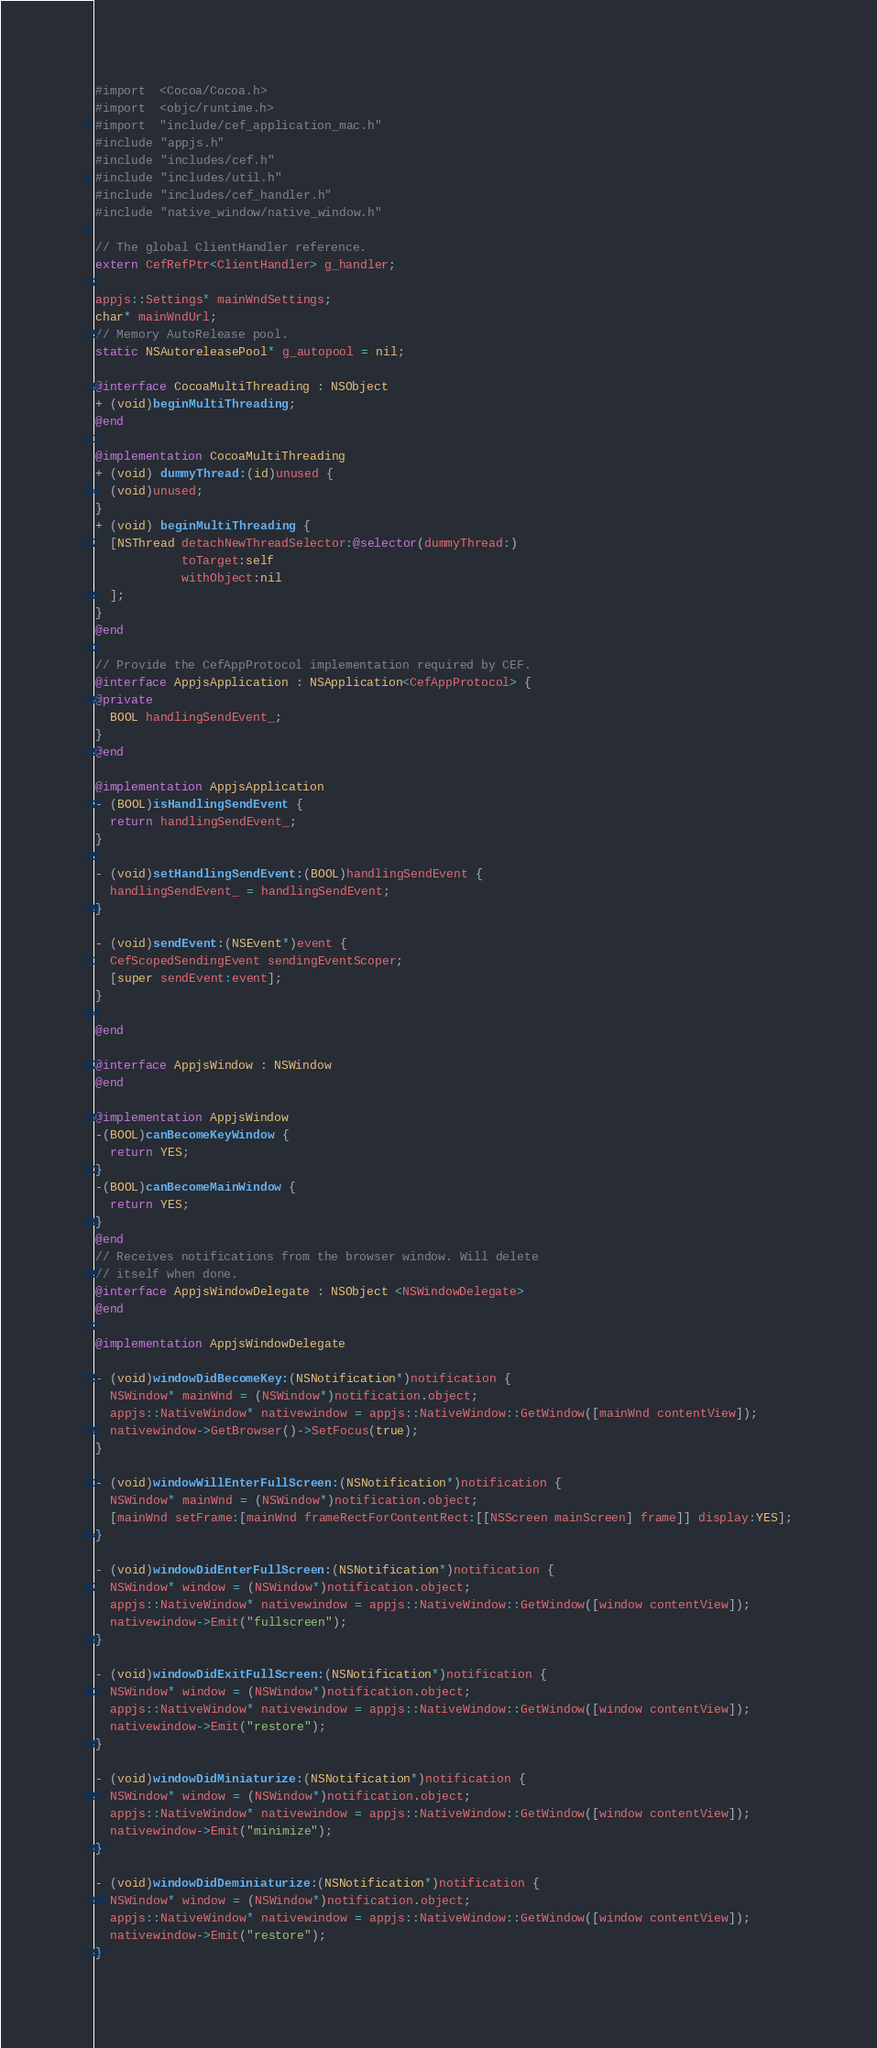Convert code to text. <code><loc_0><loc_0><loc_500><loc_500><_ObjectiveC_>#import  <Cocoa/Cocoa.h>
#import  <objc/runtime.h>
#import  "include/cef_application_mac.h"
#include "appjs.h"
#include "includes/cef.h"
#include "includes/util.h"
#include "includes/cef_handler.h"
#include "native_window/native_window.h"

// The global ClientHandler reference.
extern CefRefPtr<ClientHandler> g_handler;

appjs::Settings* mainWndSettings;
char* mainWndUrl;
// Memory AutoRelease pool.
static NSAutoreleasePool* g_autopool = nil;

@interface CocoaMultiThreading : NSObject
+ (void)beginMultiThreading;
@end

@implementation CocoaMultiThreading
+ (void) dummyThread:(id)unused {
  (void)unused;
}
+ (void) beginMultiThreading {
  [NSThread detachNewThreadSelector:@selector(dummyThread:)
            toTarget:self
            withObject:nil
  ];
}
@end

// Provide the CefAppProtocol implementation required by CEF.
@interface AppjsApplication : NSApplication<CefAppProtocol> {
@private
  BOOL handlingSendEvent_;
}
@end

@implementation AppjsApplication
- (BOOL)isHandlingSendEvent {
  return handlingSendEvent_;
}

- (void)setHandlingSendEvent:(BOOL)handlingSendEvent {
  handlingSendEvent_ = handlingSendEvent;
}

- (void)sendEvent:(NSEvent*)event {
  CefScopedSendingEvent sendingEventScoper;
  [super sendEvent:event];
}

@end

@interface AppjsWindow : NSWindow
@end

@implementation AppjsWindow
-(BOOL)canBecomeKeyWindow {
  return YES;
}
-(BOOL)canBecomeMainWindow {
  return YES;
}
@end
// Receives notifications from the browser window. Will delete
// itself when done.
@interface AppjsWindowDelegate : NSObject <NSWindowDelegate>
@end

@implementation AppjsWindowDelegate

- (void)windowDidBecomeKey:(NSNotification*)notification {
  NSWindow* mainWnd = (NSWindow*)notification.object;
  appjs::NativeWindow* nativewindow = appjs::NativeWindow::GetWindow([mainWnd contentView]);
  nativewindow->GetBrowser()->SetFocus(true);
}

- (void)windowWillEnterFullScreen:(NSNotification*)notification {
  NSWindow* mainWnd = (NSWindow*)notification.object;
  [mainWnd setFrame:[mainWnd frameRectForContentRect:[[NSScreen mainScreen] frame]] display:YES];
}

- (void)windowDidEnterFullScreen:(NSNotification*)notification {
  NSWindow* window = (NSWindow*)notification.object;
  appjs::NativeWindow* nativewindow = appjs::NativeWindow::GetWindow([window contentView]);
  nativewindow->Emit("fullscreen");
}

- (void)windowDidExitFullScreen:(NSNotification*)notification {
  NSWindow* window = (NSWindow*)notification.object;
  appjs::NativeWindow* nativewindow = appjs::NativeWindow::GetWindow([window contentView]);
  nativewindow->Emit("restore");
}

- (void)windowDidMiniaturize:(NSNotification*)notification {
  NSWindow* window = (NSWindow*)notification.object;
  appjs::NativeWindow* nativewindow = appjs::NativeWindow::GetWindow([window contentView]);
  nativewindow->Emit("minimize");
}

- (void)windowDidDeminiaturize:(NSNotification*)notification {
  NSWindow* window = (NSWindow*)notification.object;
  appjs::NativeWindow* nativewindow = appjs::NativeWindow::GetWindow([window contentView]);
  nativewindow->Emit("restore");
}
</code> 